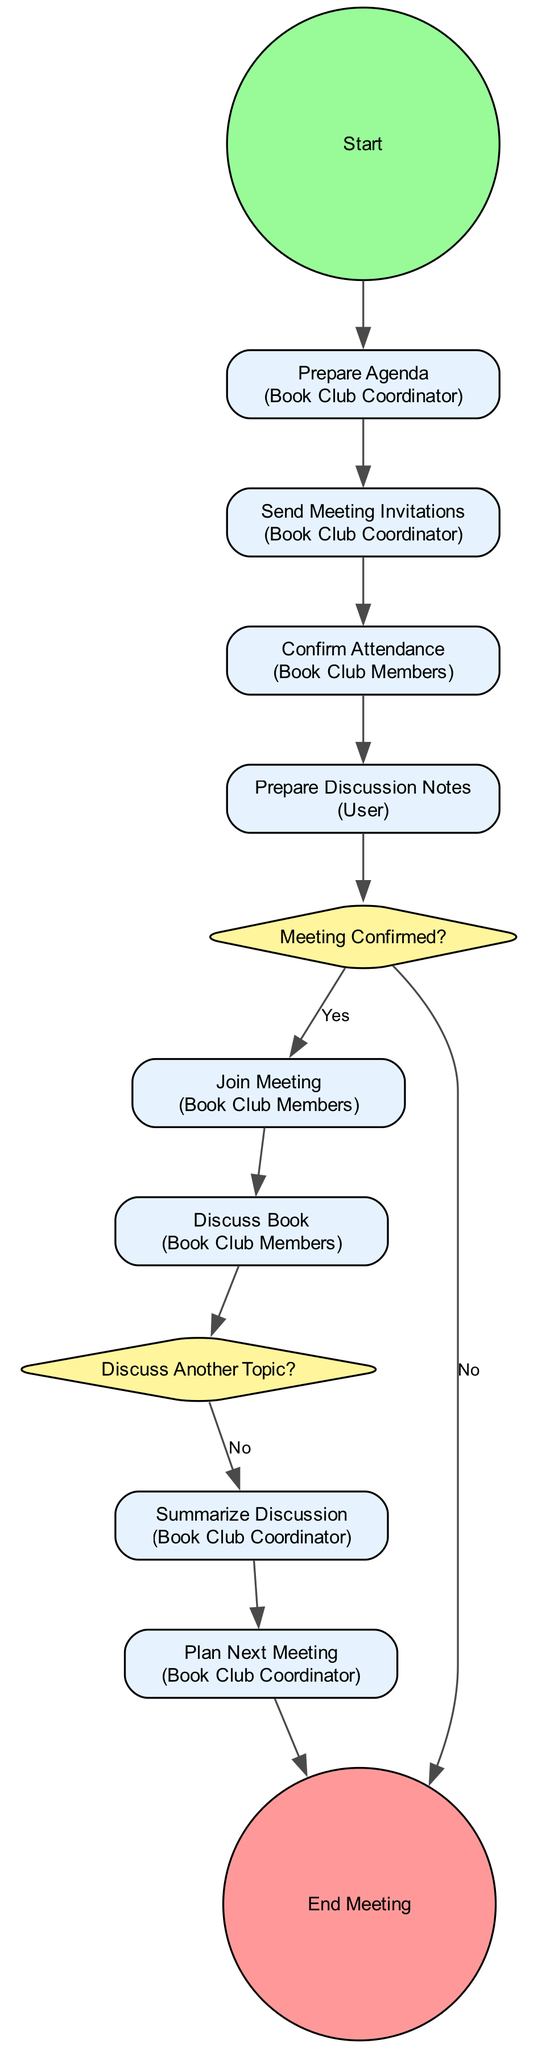What is the first activity in the diagram? The first activity in the activity diagram is "Prepare Agenda," which is connected directly to the start node.
Answer: Prepare Agenda How many participants are involved in the book club meeting process? The diagram indicates three participants: User, Book Club Coordinator, and Book Club Members.
Answer: Three What is the decision point after preparing discussion notes? The decision point after preparing discussion notes is "Meeting Confirmed?" which assesses if enough members have confirmed attendance.
Answer: Meeting Confirmed? Which activity is performed by the Book Club Members following the confirmation of attendance? Following the confirmation of attendance, the next activity performed by the Book Club Members is "Join Meeting," where they log in to the virtual platform.
Answer: Join Meeting What happens if the meeting is not confirmed? If the meeting is not confirmed, the flow directs to the end of the meeting process, concluding the meeting without proceeding to the discussion.
Answer: End Meeting How does the coordinator summarize the discussion? After the discussion, the Book Club Coordinator summarizes key points and gathers feedback from members before considering any next steps.
Answer: Summarize Discussion Which activity comes after the discussion of the book? The activity that follows the discussion of the book is "Plan Next Meeting," where the coordinator discusses the next book and records member preferences.
Answer: Plan Next Meeting What is the final action in the meeting process? The final action in the meeting process is "End Meeting," which concludes the meeting and thanks participants for attending.
Answer: End Meeting Is there a decision point where the discussion can switch topics? Yes, there is a decision point called "Discuss Another Topic?" that determines if the discussion should continue with another topic or book.
Answer: Discuss Another Topic? 